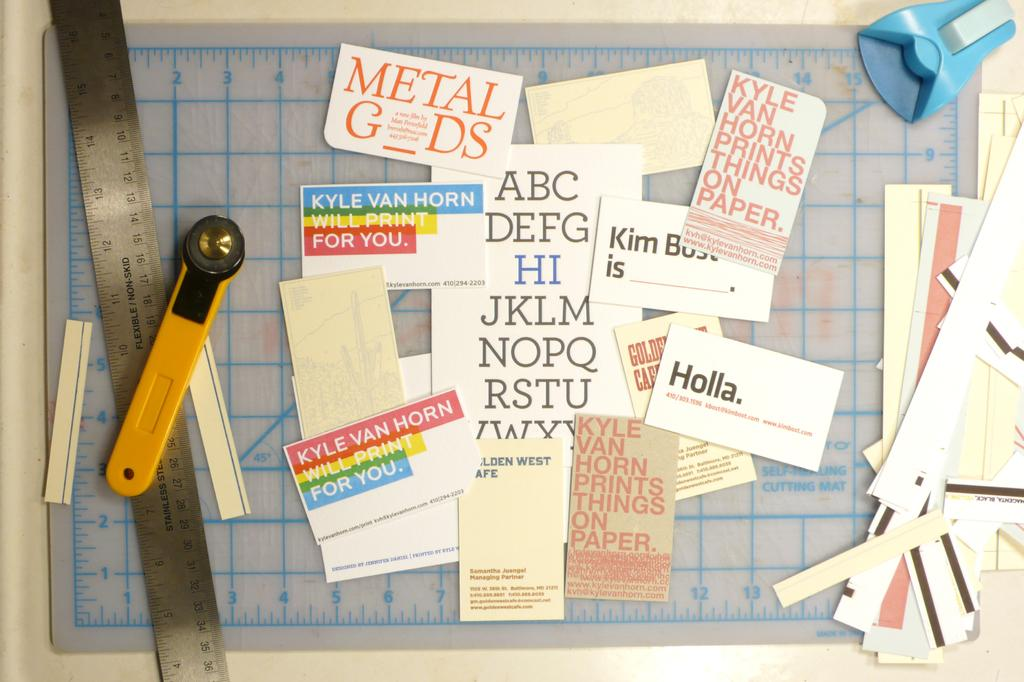Provide a one-sentence caption for the provided image. A measuring stick and other scrap booking tools with phrases cut out of magazines showing the alphabet, holla, and other phrases. 